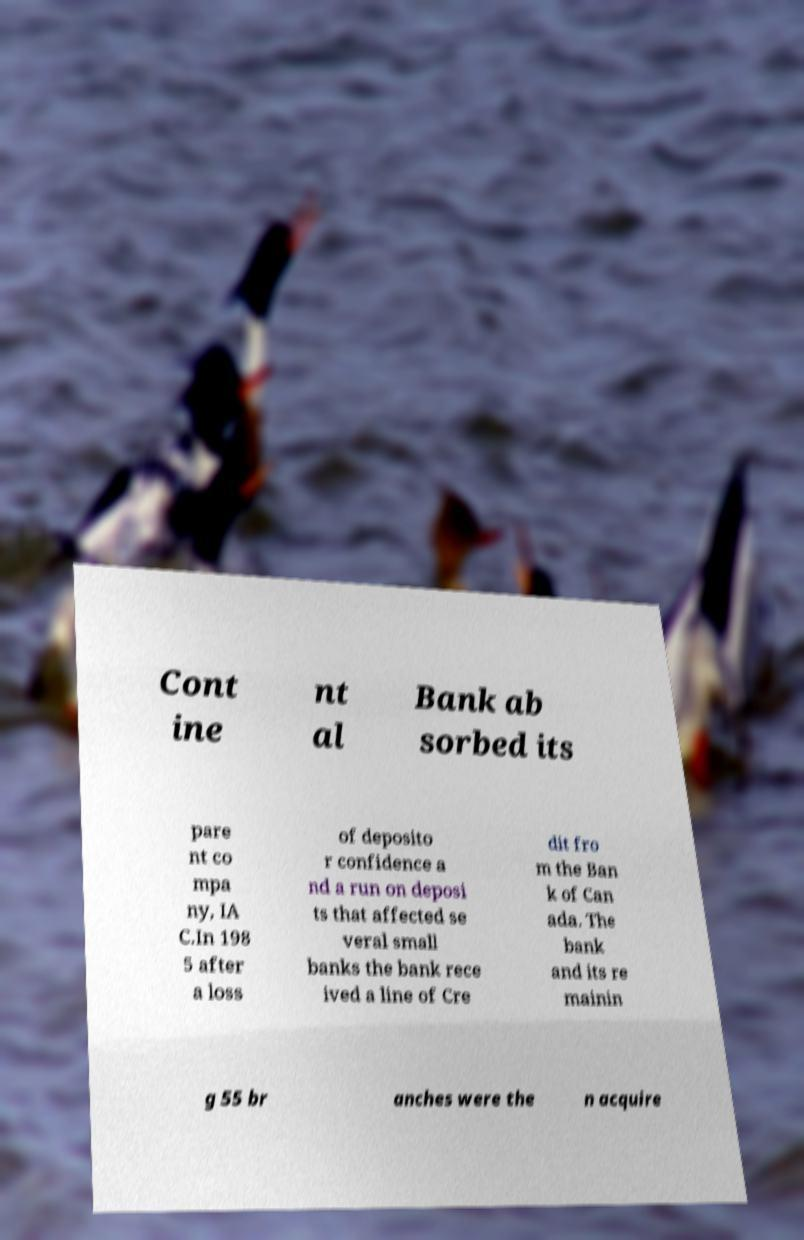I need the written content from this picture converted into text. Can you do that? Cont ine nt al Bank ab sorbed its pare nt co mpa ny, IA C.In 198 5 after a loss of deposito r confidence a nd a run on deposi ts that affected se veral small banks the bank rece ived a line of Cre dit fro m the Ban k of Can ada. The bank and its re mainin g 55 br anches were the n acquire 